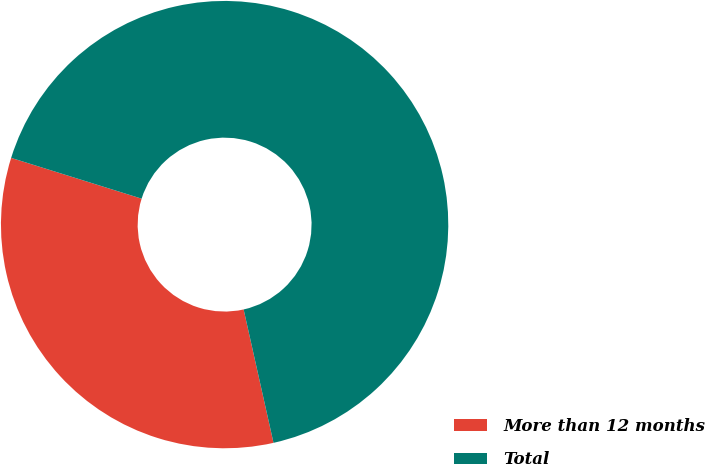Convert chart. <chart><loc_0><loc_0><loc_500><loc_500><pie_chart><fcel>More than 12 months<fcel>Total<nl><fcel>33.33%<fcel>66.67%<nl></chart> 